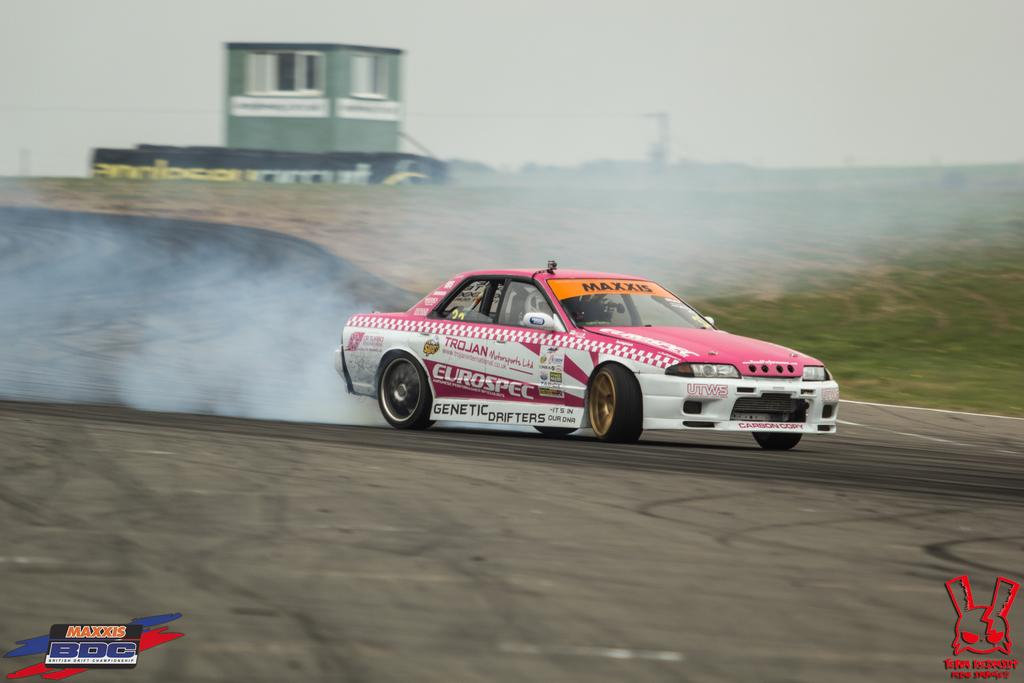What is the main subject of the image? The main subject of the image is a car. What is the car doing in the image? The car is moving on the road in the image. Can you describe the person inside the car? There is a person sitting inside the car. What can be seen in the background of the image? There is a building in the background of the image, and it has windows. Are there any other notable features of the image? Yes, there are watermarks on the image. What type of egg is the person holding while performing a bone-related activity in the image? There is no egg or bone-related activity present in the image; it features a car moving on the road with a person sitting inside and a building in the background. 